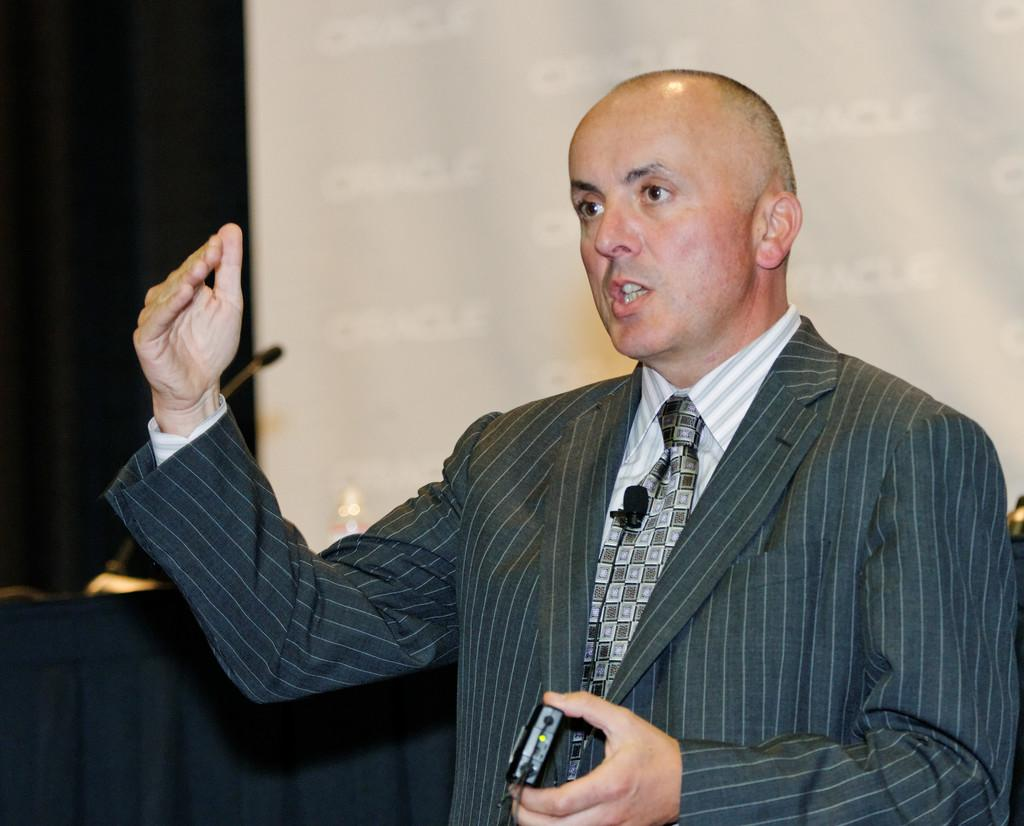What is the main subject of the image? The main subject of the image is a man. What is the man wearing in the image? The man is wearing a blazer in the image. What is the man holding in the image? The man is holding an object in the image. What might the man be doing in the image? The man appears to be explaining something in the image. What can be seen in the background of the image? In the background of the image, there is a cloth, a microphone, and a projector screen. Is the judge present in the image? There is no judge present in the image. What type of existence does the front have in the image? The term "front" does not refer to a specific object or person in the image, so it does not have a particular existence in the image. 